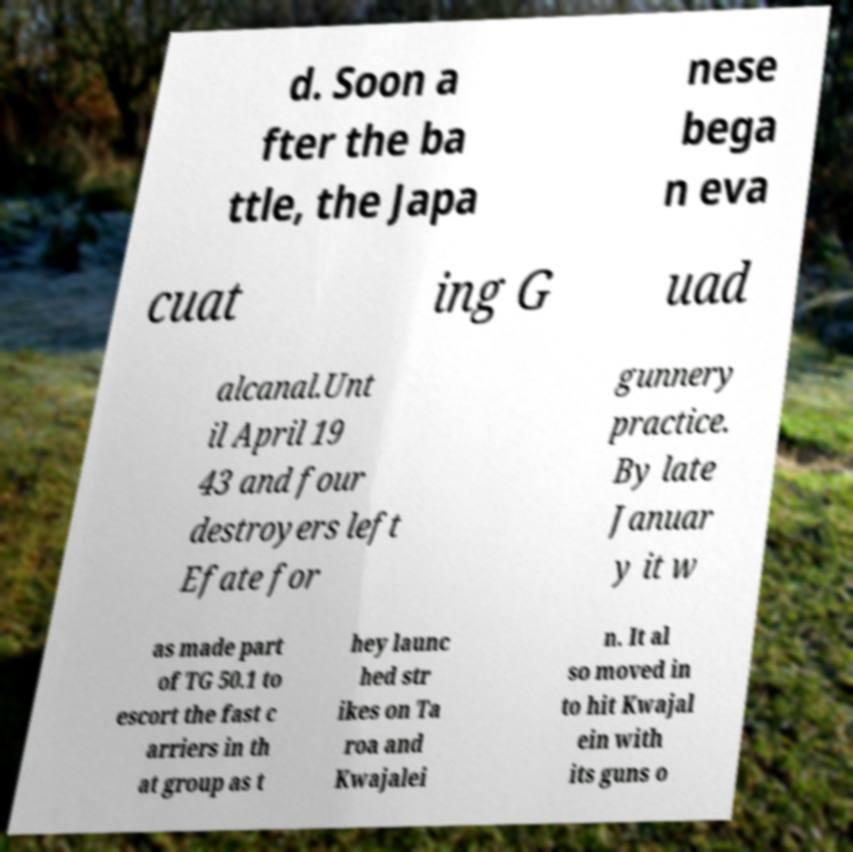Can you accurately transcribe the text from the provided image for me? d. Soon a fter the ba ttle, the Japa nese bega n eva cuat ing G uad alcanal.Unt il April 19 43 and four destroyers left Efate for gunnery practice. By late Januar y it w as made part of TG 50.1 to escort the fast c arriers in th at group as t hey launc hed str ikes on Ta roa and Kwajalei n. It al so moved in to hit Kwajal ein with its guns o 